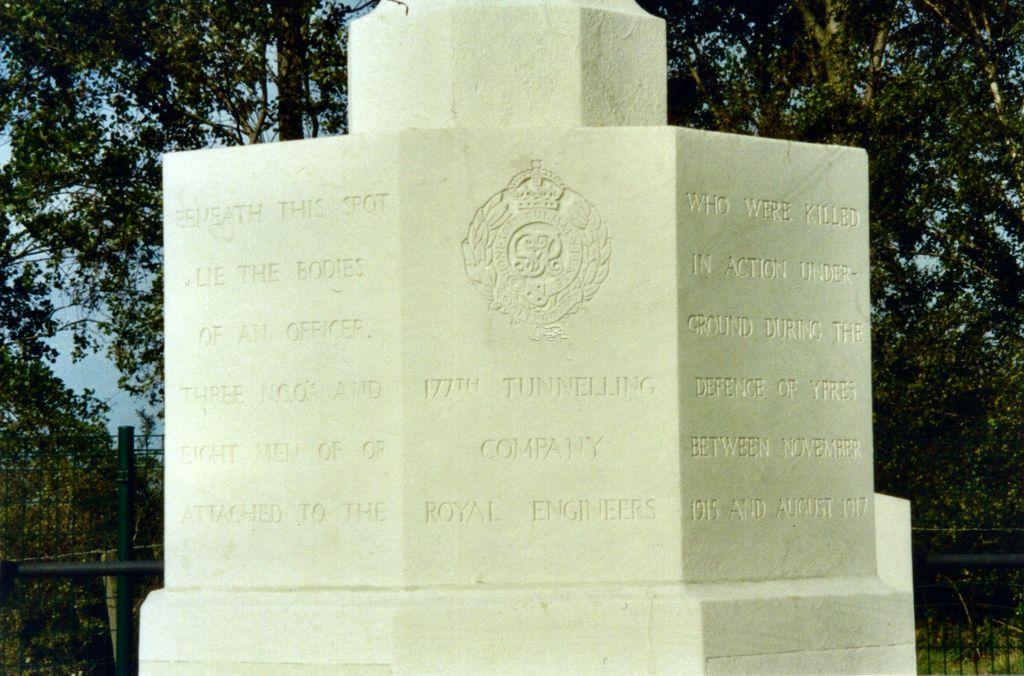What is the main subject in the image? There is a memorial stone in the image. What can be seen at the bottom left and right of the image? There is fencing in the bottom left and bottom right of the image. What type of natural elements are visible in the background of the image? There are trees in the background of the image. What is the rate of the parcels being delivered to the land in the image? There is no mention of parcels or land in the image; it features a memorial stone and fencing. 